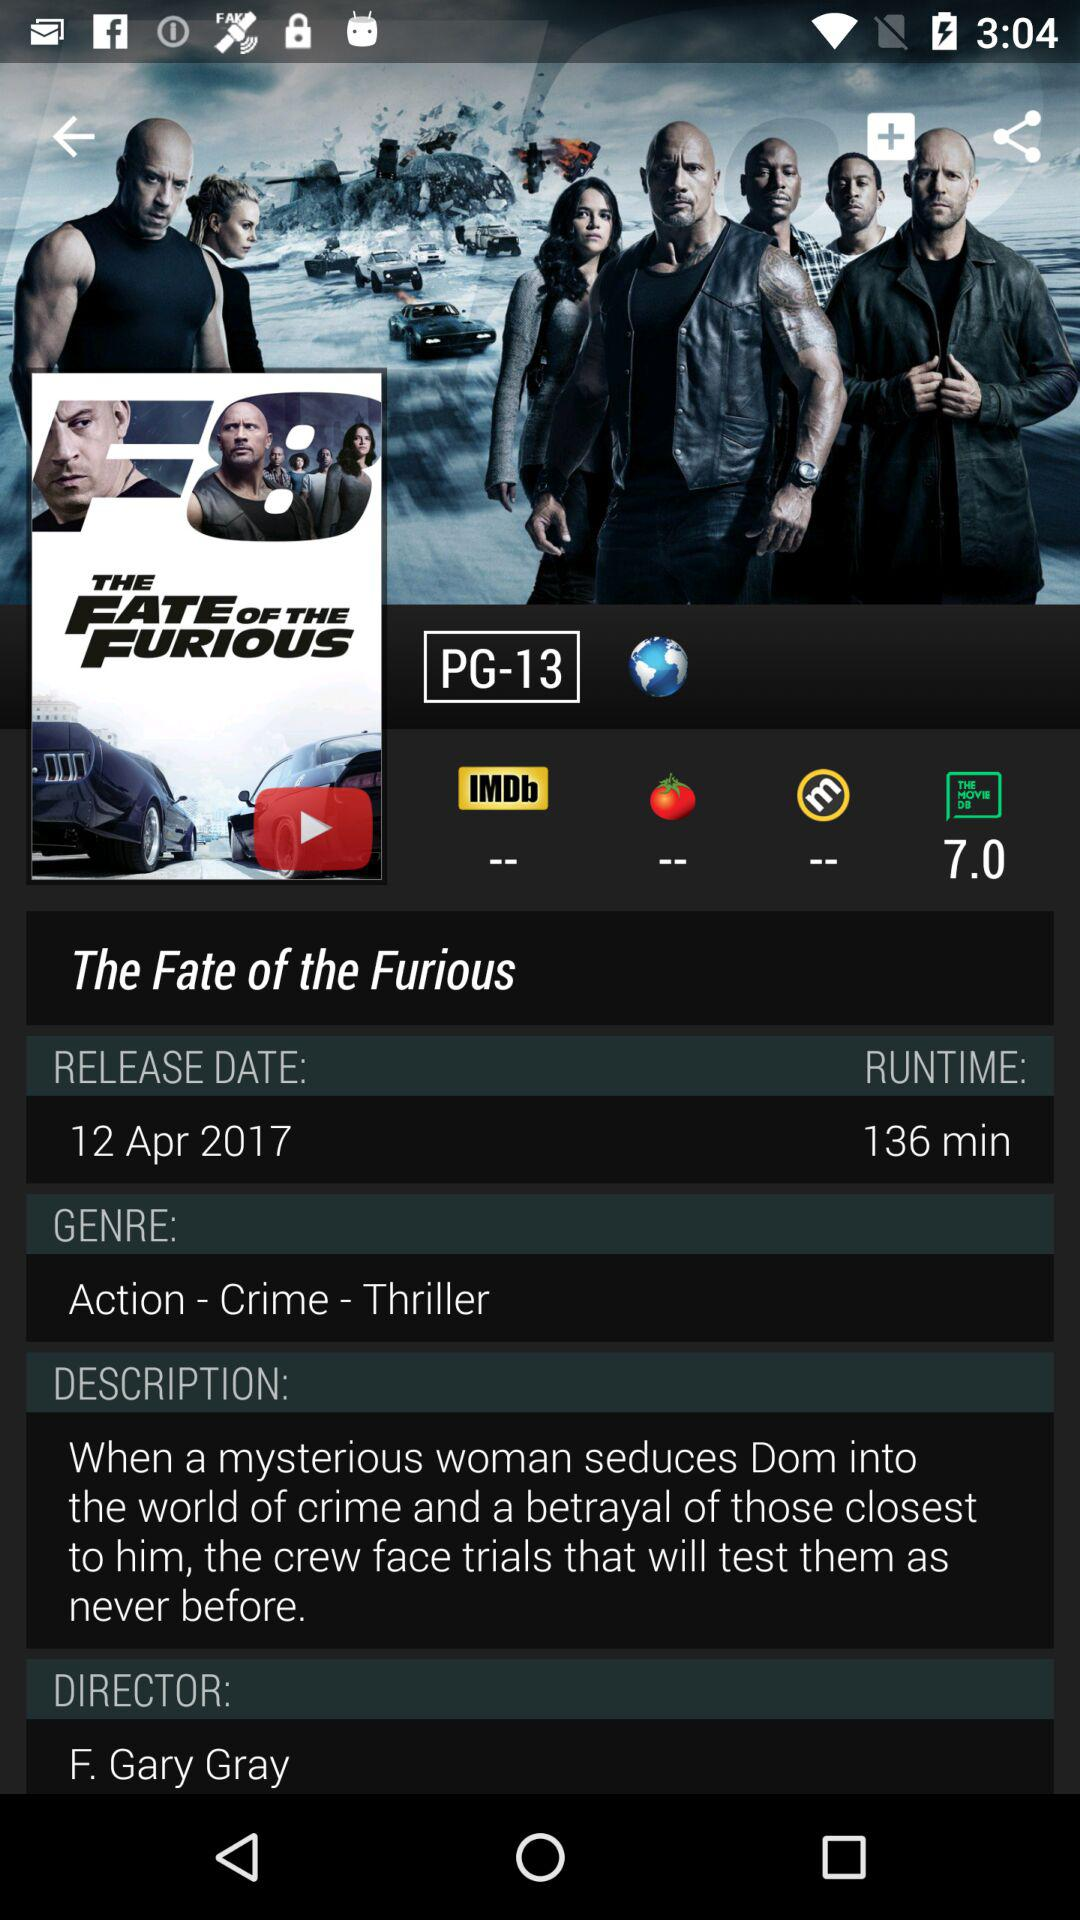What is the rating of the movie? The rating of the movie is 7.0. 